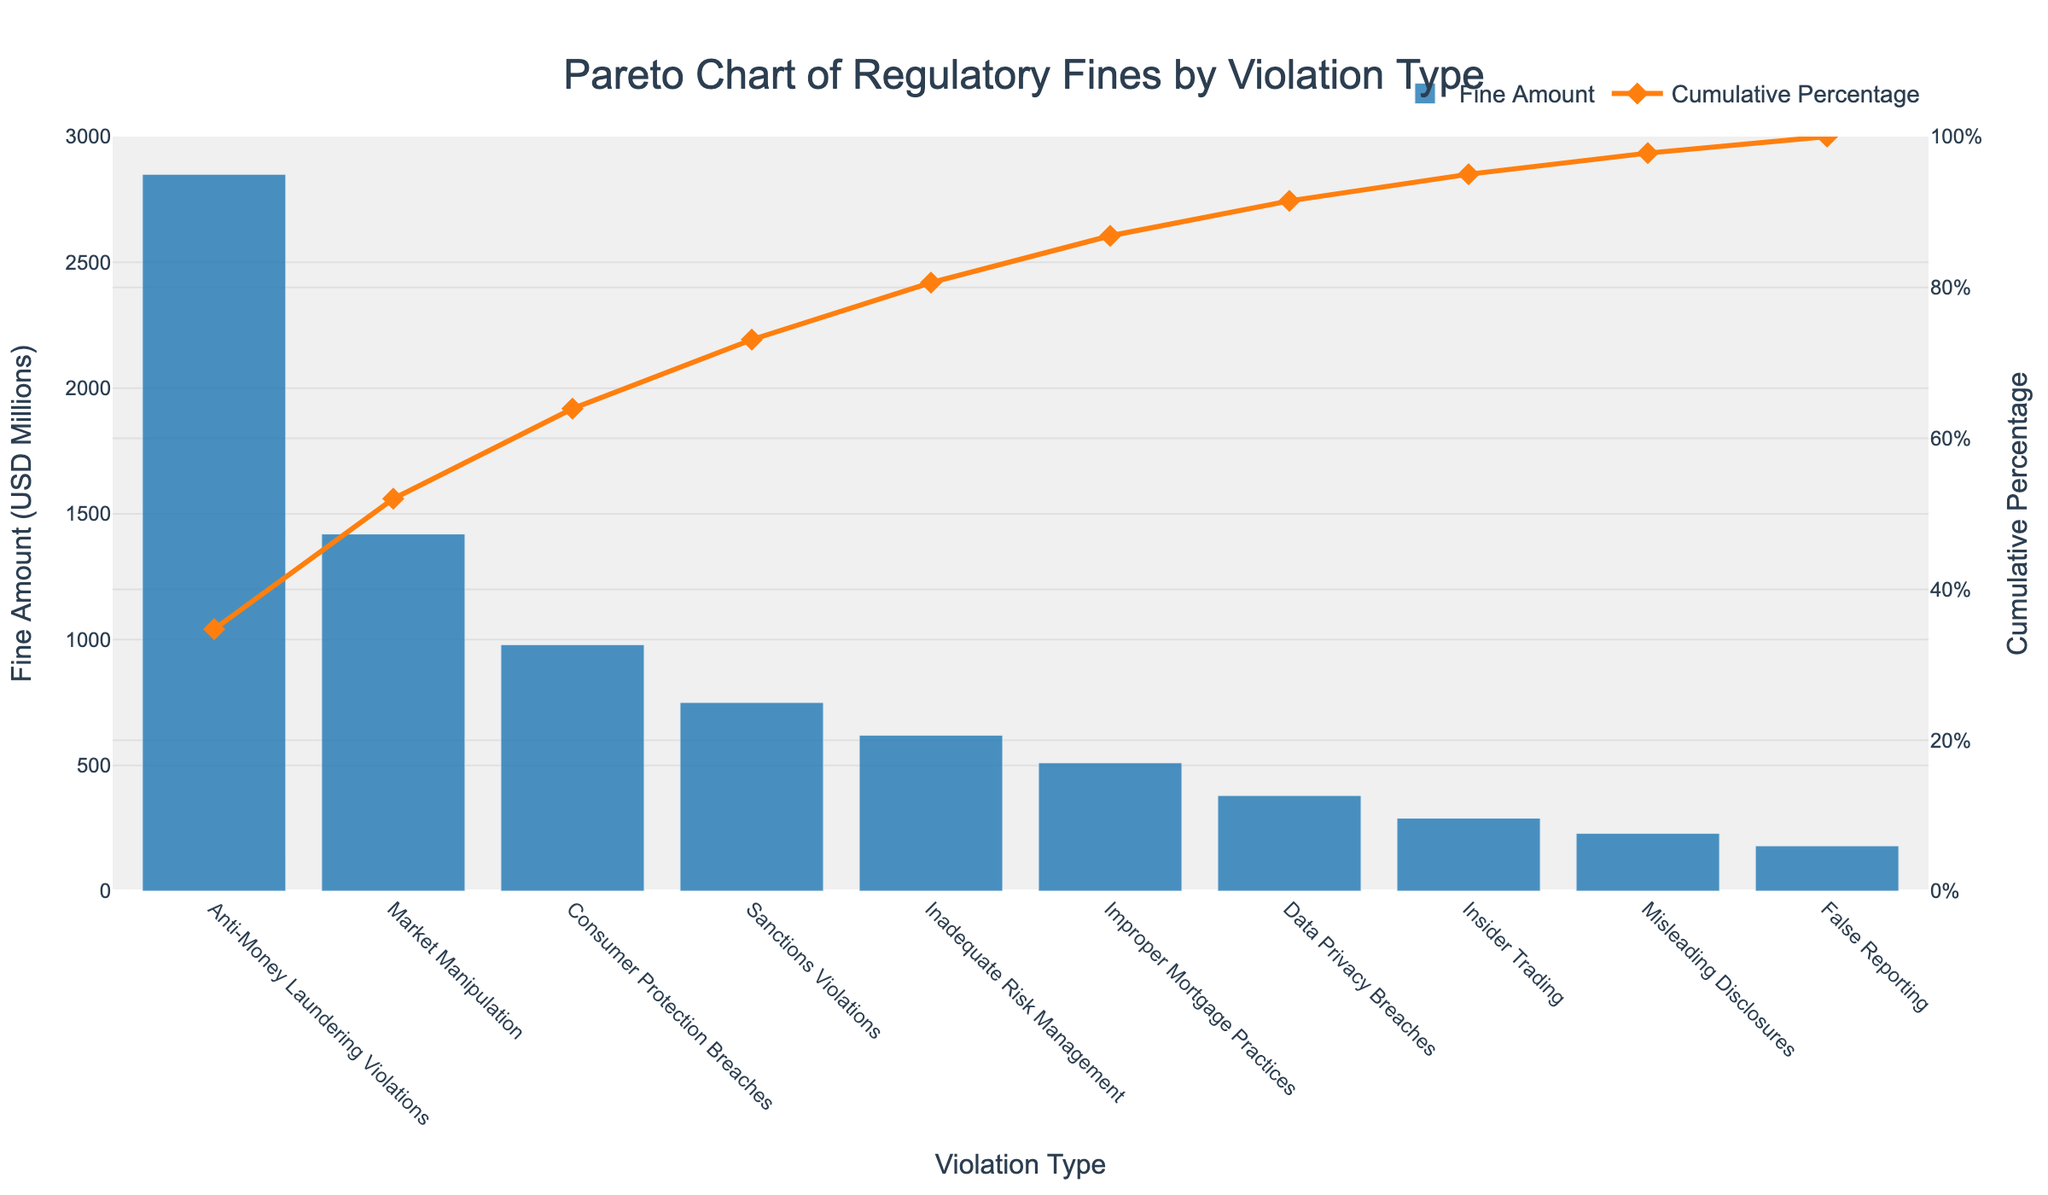What's the title of the figure? The title of the figure is found at the top center and typically summarizes the subject matter of the plot.
Answer: Pareto Chart of Regulatory Fines by Violation Type Which violation type has incurred the highest fine amount? By looking at the tallest bar on the left-hand side of the figure, we can identify the violation type with the highest fine.
Answer: Anti-Money Laundering Violations What is the cumulative percentage at the fourth highest violation type? Locate the fourth data point on the line chart representing the cumulative percentage and read its value on the right y-axis.
Answer: 82.43% How much is the total fine amount for the top three violation types combined? Sum the fine amounts of the first three tallest bars from the left: 2850 (Anti-Money Laundering) + 1420 (Market Manipulation) + 980 (Consumer Protection Breaches).
Answer: 5250 million USD By how many percent do Anti-Money Laundering and Market Manipulation violations together contribute to the total fine amount? Add the fine amounts for Anti-Money Laundering and Market Manipulation (2850 + 1420), then calculate their combined percentage of the total fines.
Answer: 56.54% How does the fine amount for Improper Mortgage Practices compare to that for Data Privacy Breaches? Locate the Data Privacy Breaches and Improper Mortgage Practices bars, then compare their heights to determine the relative difference.
Answer: Improper Mortgage Practices is higher Which violation types contribute to achieving over 75% of the total fines? Examine the cumulative percentage line and identify the violation types up until the cumulative percentage exceeds 75%.
Answer: Anti-Money Laundering Violations, Market Manipulation, Consumer Protection Breaches, and Sanctions Violations What is the fine amount for Misleading Disclosures? Find the bar representing Misleading Disclosures and read the corresponding value on the left y-axis.
Answer: 230 million USD What's the cumulative percentage after the first five violation types? Check the cumulative percentage value at the fifth violation type on the line chart.
Answer: 84.89% What percentage of the total fine amount is attributed to False Reporting? Divide the False Reporting fine amount (180) by the total sum of fines (accounted for all violation types), then multiply by 100 to get the percentage.
Answer: 2.38% 